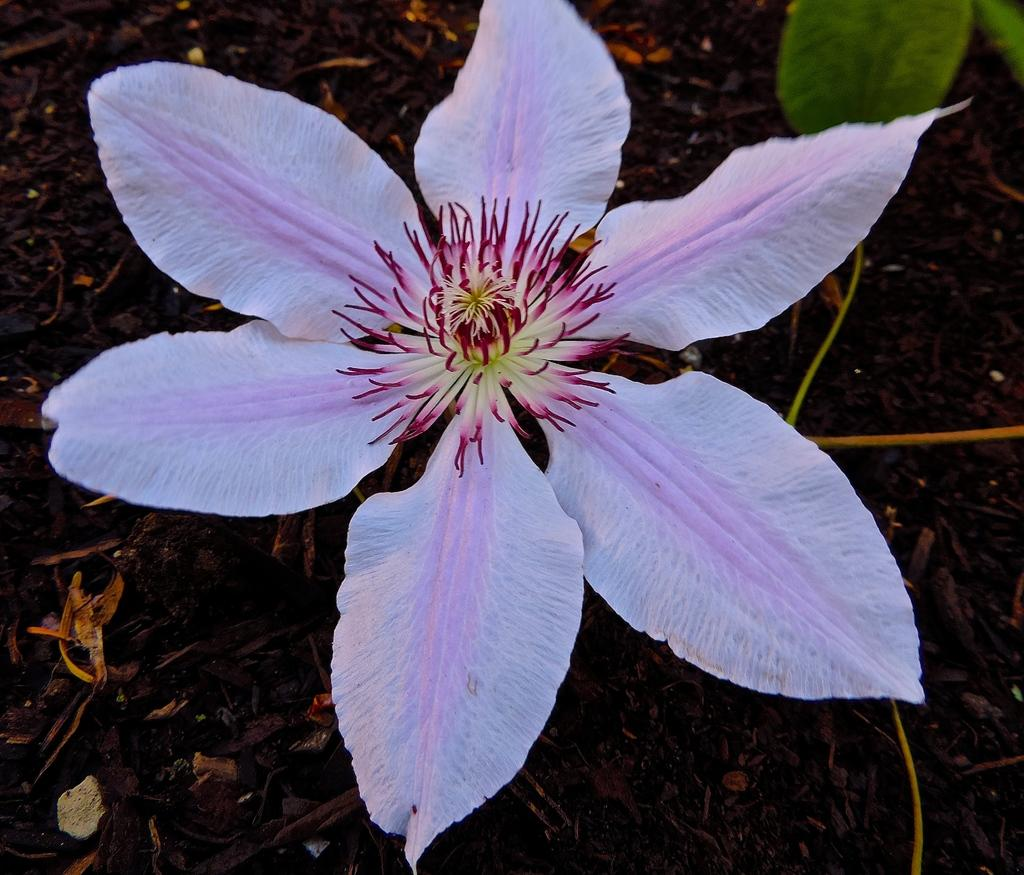What type of living organism can be seen in the image? There is a flower on a plant in the image. Where is the plant located? The plant is on a surface in the image. What type of square can be seen in the image? There is no square present in the image; it features a flower on a plant. Can you tell me how many matches are visible in the image? There are no matches present in the image. 